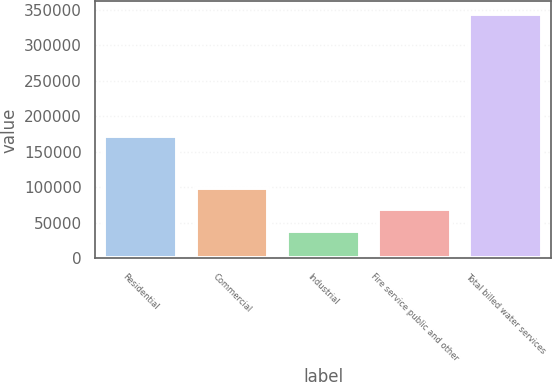Convert chart. <chart><loc_0><loc_0><loc_500><loc_500><bar_chart><fcel>Residential<fcel>Commercial<fcel>Industrial<fcel>Fire service public and other<fcel>Total billed water services<nl><fcel>172827<fcel>99642<fcel>38432<fcel>69037<fcel>344482<nl></chart> 